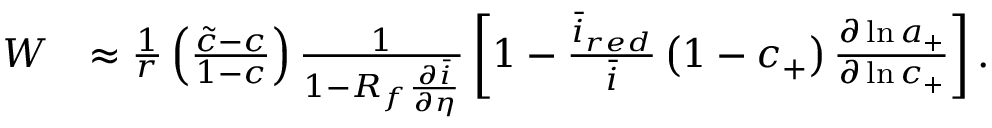<formula> <loc_0><loc_0><loc_500><loc_500>\begin{array} { r l } { W } & { \approx \frac { 1 } { r } \left ( \frac { \tilde { c } - c } { 1 - c } \right ) \frac { 1 } { 1 - R _ { f } \frac { \partial \bar { i } } { \partial \eta } } \left [ 1 - \frac { \bar { i } _ { r e d } } { \bar { i } } \left ( 1 - c _ { + } \right ) \frac { \partial \ln { a _ { + } } } { \partial \ln { c _ { + } } } \right ] . } \end{array}</formula> 